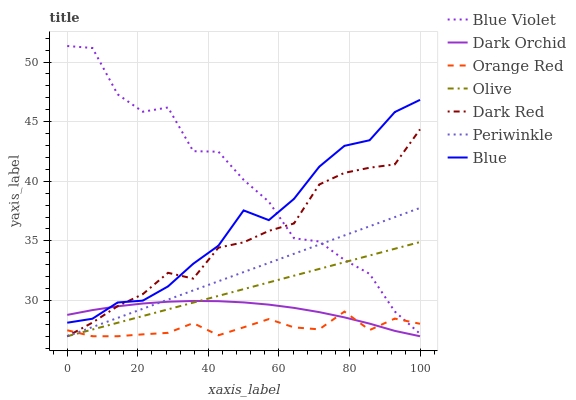Does Dark Red have the minimum area under the curve?
Answer yes or no. No. Does Dark Red have the maximum area under the curve?
Answer yes or no. No. Is Dark Red the smoothest?
Answer yes or no. No. Is Dark Red the roughest?
Answer yes or no. No. Does Blue Violet have the lowest value?
Answer yes or no. No. Does Dark Red have the highest value?
Answer yes or no. No. Is Orange Red less than Blue?
Answer yes or no. Yes. Is Blue greater than Periwinkle?
Answer yes or no. Yes. Does Orange Red intersect Blue?
Answer yes or no. No. 